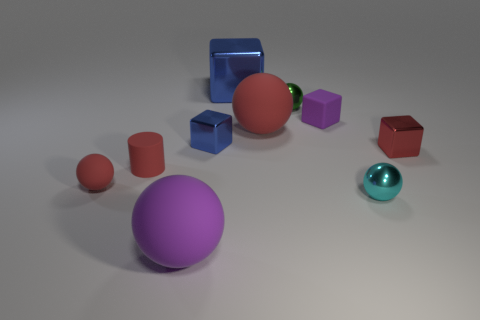Subtract 1 blocks. How many blocks are left? 3 Subtract all big balls. How many balls are left? 3 Subtract all red cubes. How many cubes are left? 3 Subtract all cyan spheres. Subtract all blue blocks. How many spheres are left? 4 Subtract all cubes. How many objects are left? 6 Subtract all small red shiny blocks. Subtract all rubber balls. How many objects are left? 6 Add 5 small cyan things. How many small cyan things are left? 6 Add 6 small purple cubes. How many small purple cubes exist? 7 Subtract 0 cyan cubes. How many objects are left? 10 